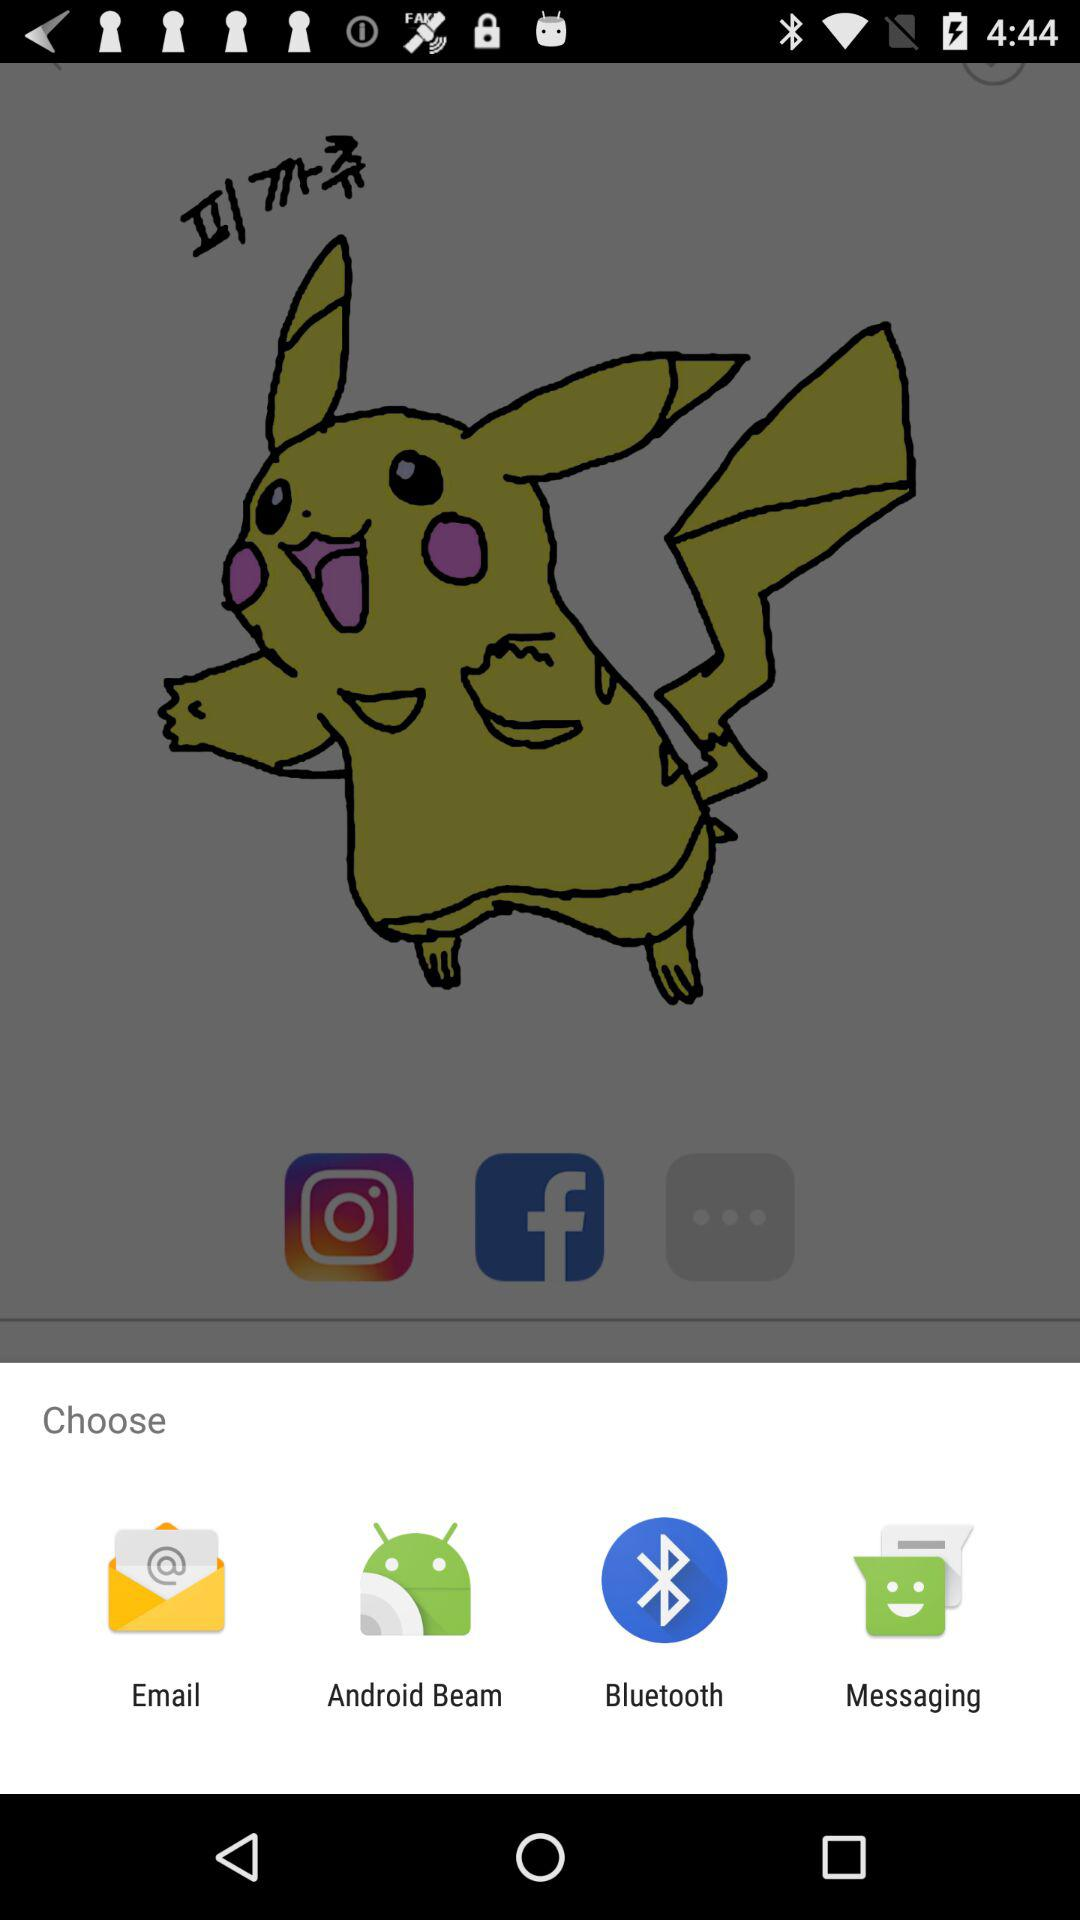Through which application can content be shared?
When the provided information is insufficient, respond with <no answer>. <no answer> 